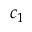Convert formula to latex. <formula><loc_0><loc_0><loc_500><loc_500>c _ { 1 }</formula> 